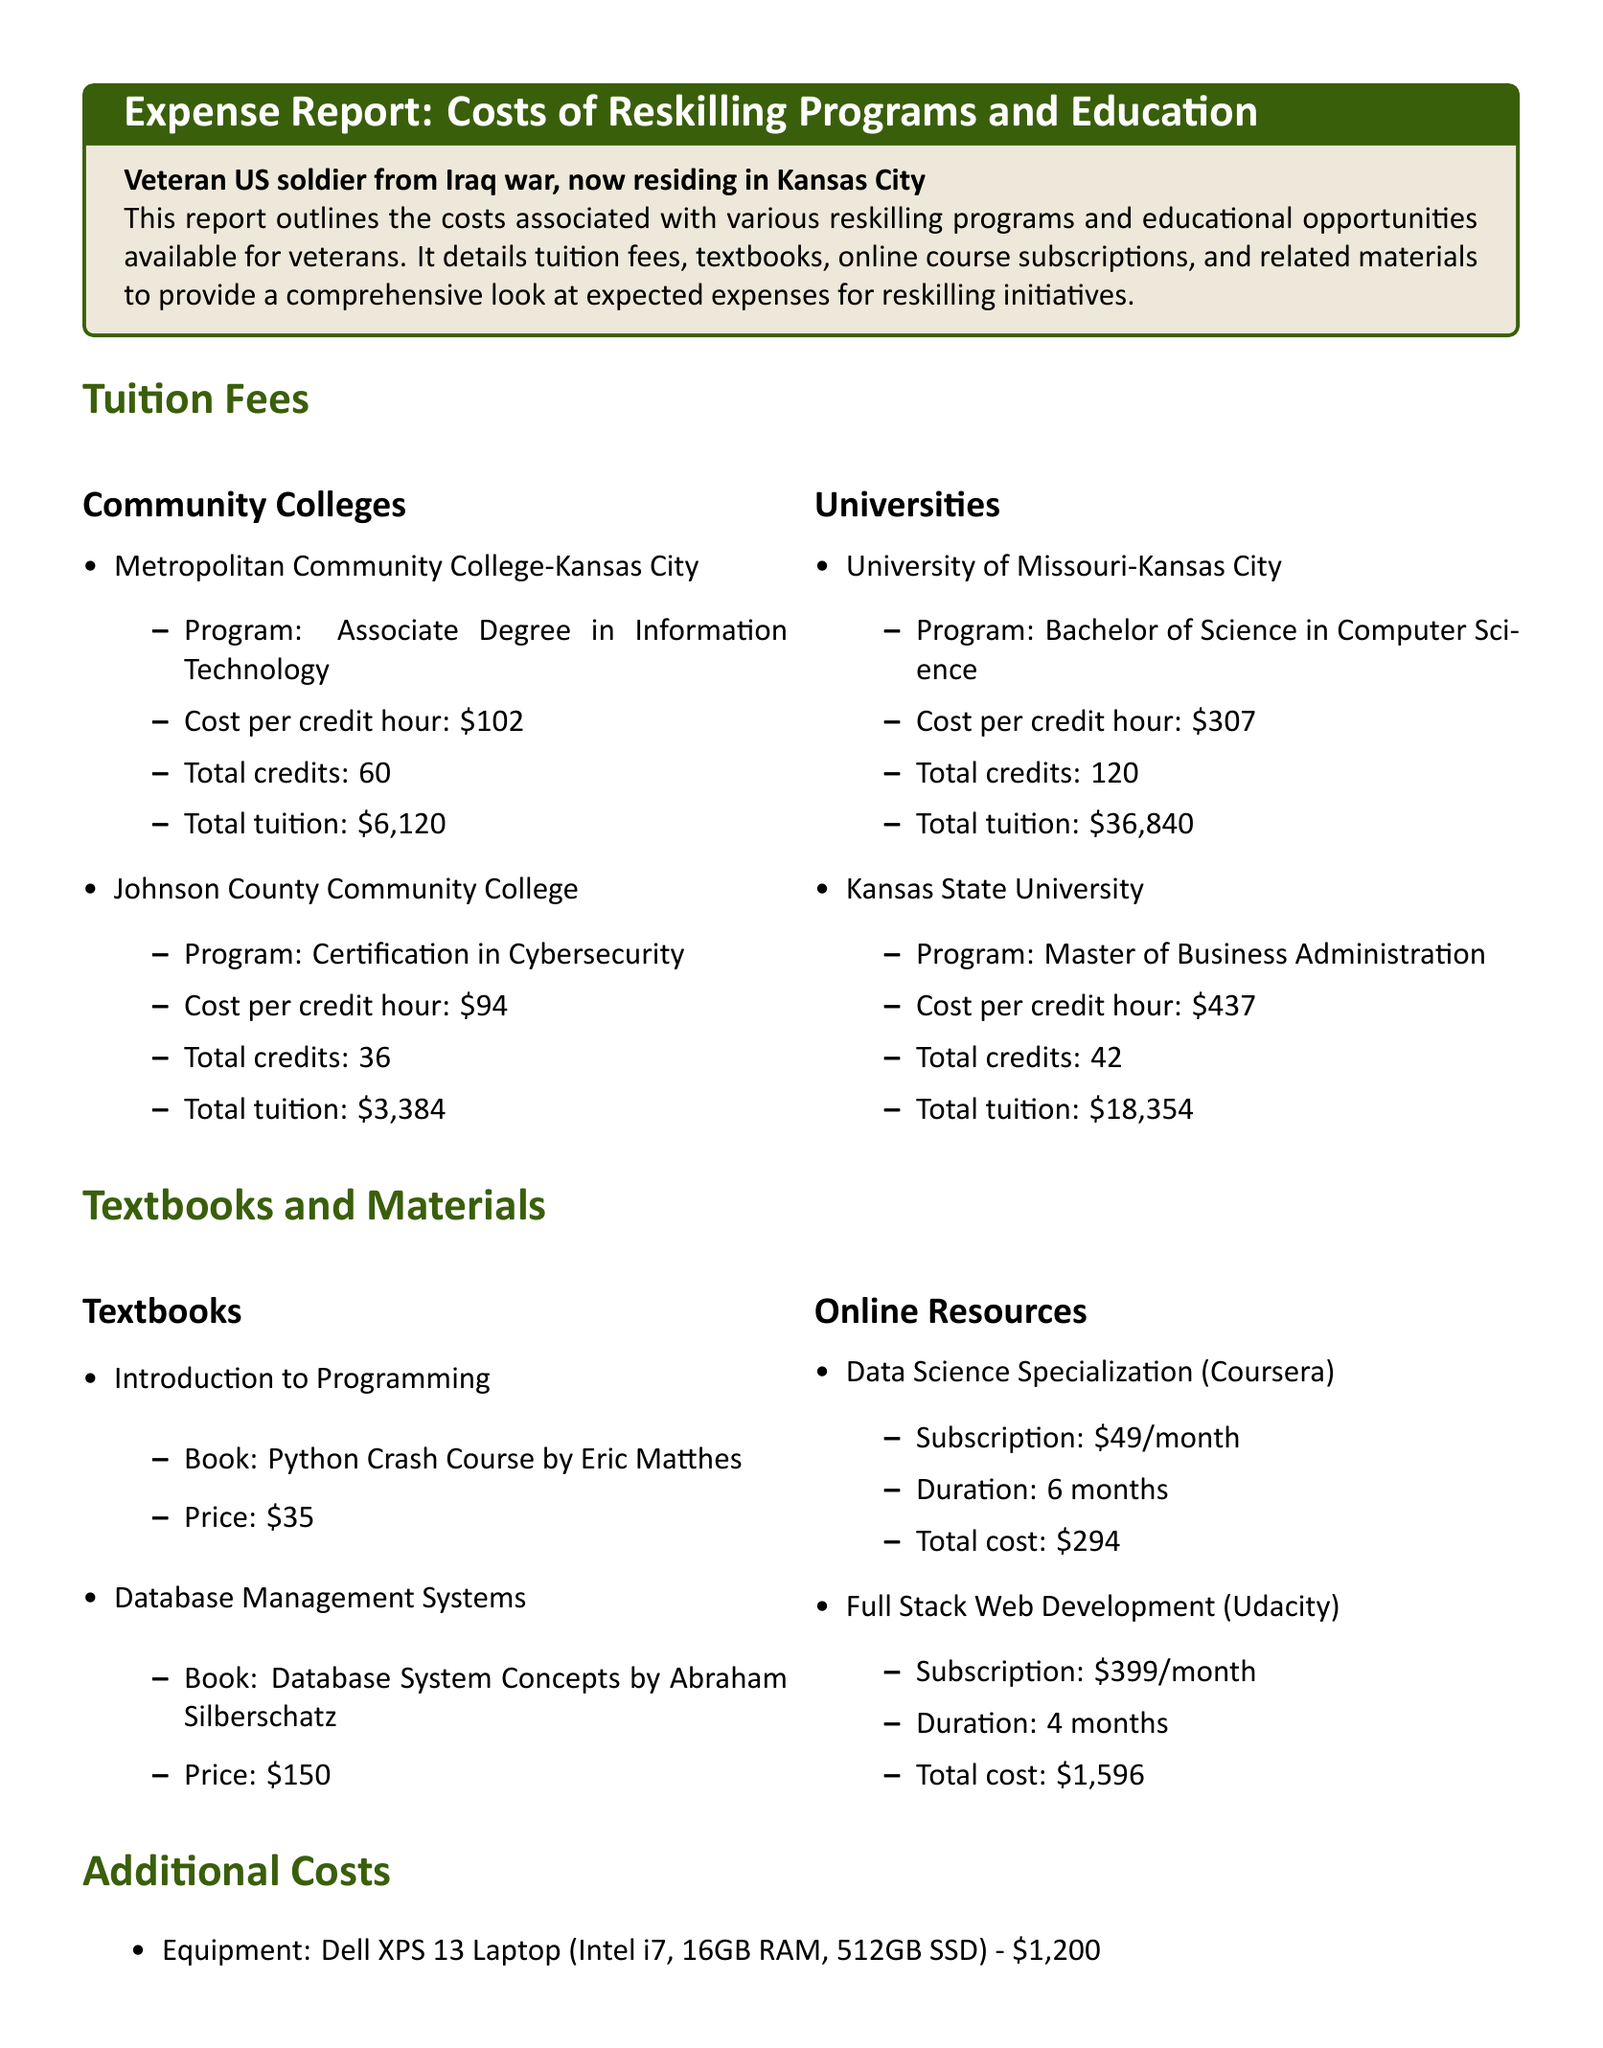What is the tuition cost for the Associate Degree in Information Technology at Metropolitan Community College? The tuition cost is derived from the cost per credit hour multiplied by the total credits, which is $102 per credit hour for 60 credits.
Answer: $6,120 What is the price of the book "Database System Concepts"? This price is listed in the textbooks section and provides specific costs for educational materials.
Answer: $150 How much does the Full Stack Web Development course at Udacity cost in total? The total cost is calculated based on the monthly subscription fee and duration, which is $399 per month for 4 months.
Answer: $1,596 What is the total tuition for the Master of Business Administration at Kansas State University? The total is calculated using the cost per credit hour and total credits, which is $437 per credit hour for 42 credits.
Answer: $18,354 Which community college offers a Certification in Cybersecurity? This identifies the institution that provides the specific program mentioned in the document.
Answer: Johnson County Community College How many months is the duration of the Data Science Specialization course on Coursera? This duration is explicitly mentioned in the online resources section and provides essential planning information.
Answer: 6 months What is the total number of credits needed for the Bachelor of Science in Computer Science at University of Missouri-Kansas City? The required credits listed in the tuition fees section provide direct information for potential students.
Answer: 120 What is the total cost for the Dell XPS 13 Laptop? The price is indicated as an additional cost and important factor for reskilling resources.
Answer: $1,200 Which textbook costs $35? This specifically points to the educational resource that is less expensive among the listed textbooks.
Answer: Python Crash Course by Eric Matthes 